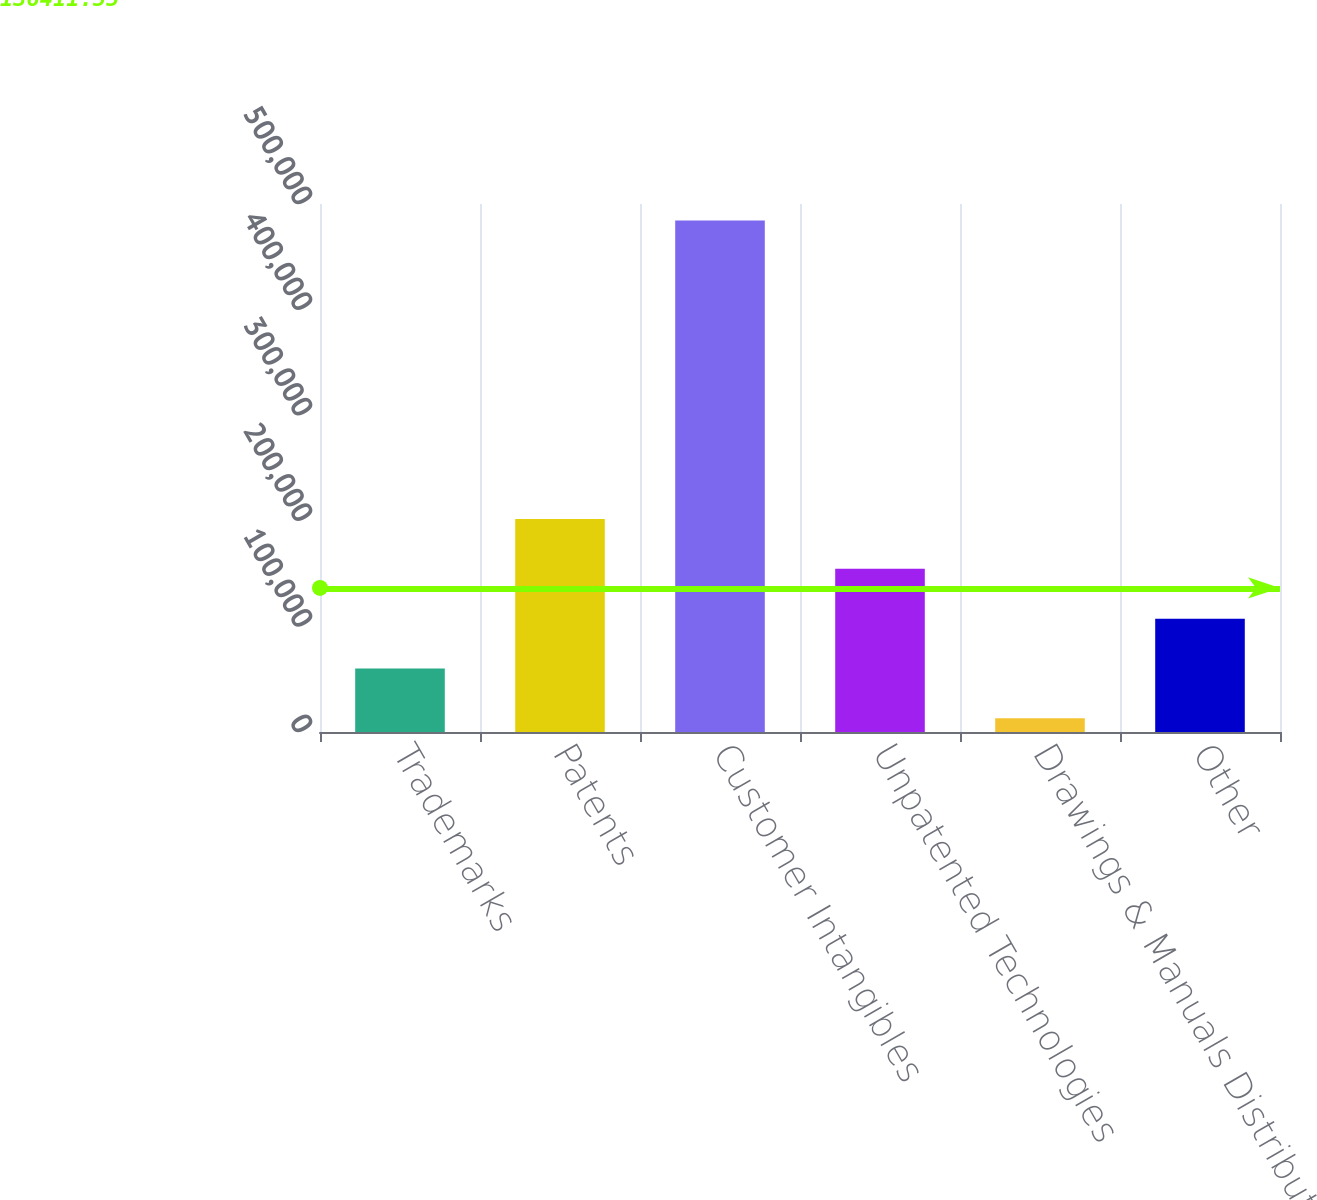Convert chart. <chart><loc_0><loc_0><loc_500><loc_500><bar_chart><fcel>Trademarks<fcel>Patents<fcel>Customer Intangibles<fcel>Unpatented Technologies<fcel>Drawings & Manuals Distributor<fcel>Other<nl><fcel>60223.2<fcel>201632<fcel>484449<fcel>154496<fcel>13087<fcel>107359<nl></chart> 